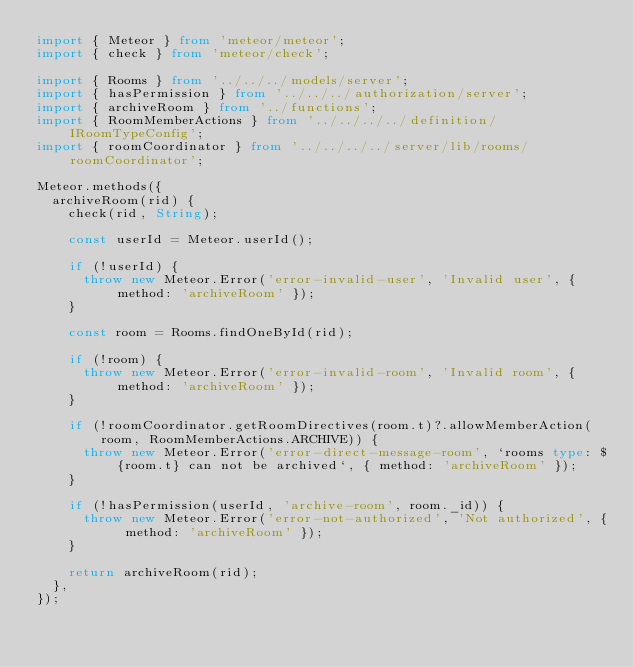<code> <loc_0><loc_0><loc_500><loc_500><_TypeScript_>import { Meteor } from 'meteor/meteor';
import { check } from 'meteor/check';

import { Rooms } from '../../../models/server';
import { hasPermission } from '../../../authorization/server';
import { archiveRoom } from '../functions';
import { RoomMemberActions } from '../../../../definition/IRoomTypeConfig';
import { roomCoordinator } from '../../../../server/lib/rooms/roomCoordinator';

Meteor.methods({
	archiveRoom(rid) {
		check(rid, String);

		const userId = Meteor.userId();

		if (!userId) {
			throw new Meteor.Error('error-invalid-user', 'Invalid user', { method: 'archiveRoom' });
		}

		const room = Rooms.findOneById(rid);

		if (!room) {
			throw new Meteor.Error('error-invalid-room', 'Invalid room', { method: 'archiveRoom' });
		}

		if (!roomCoordinator.getRoomDirectives(room.t)?.allowMemberAction(room, RoomMemberActions.ARCHIVE)) {
			throw new Meteor.Error('error-direct-message-room', `rooms type: ${room.t} can not be archived`, { method: 'archiveRoom' });
		}

		if (!hasPermission(userId, 'archive-room', room._id)) {
			throw new Meteor.Error('error-not-authorized', 'Not authorized', { method: 'archiveRoom' });
		}

		return archiveRoom(rid);
	},
});
</code> 